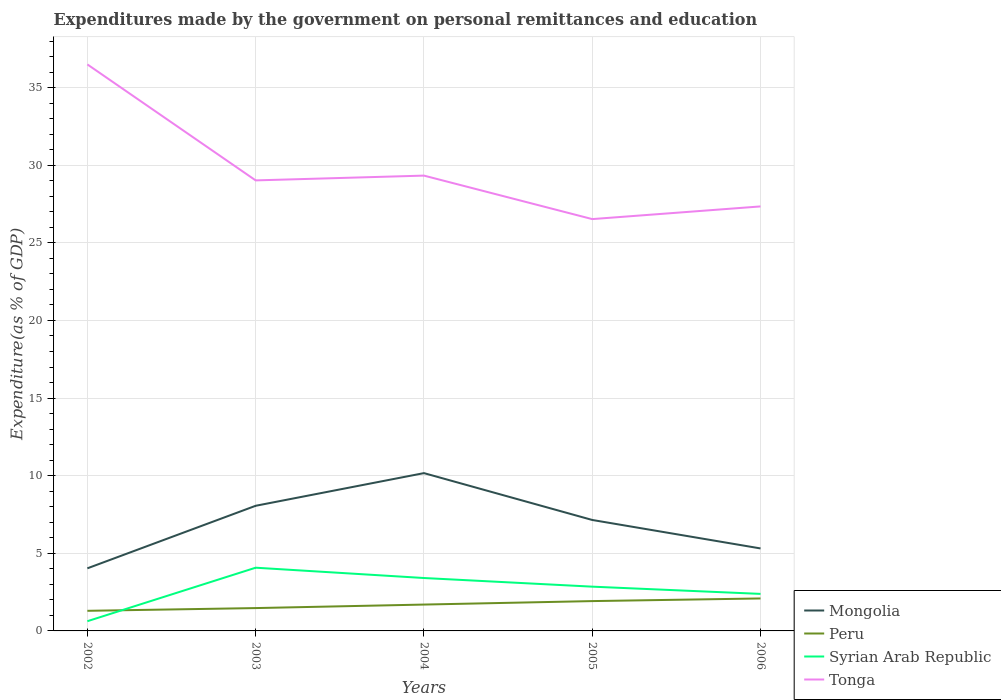Across all years, what is the maximum expenditures made by the government on personal remittances and education in Tonga?
Provide a succinct answer. 26.53. What is the total expenditures made by the government on personal remittances and education in Tonga in the graph?
Provide a succinct answer. 1.98. What is the difference between the highest and the second highest expenditures made by the government on personal remittances and education in Syrian Arab Republic?
Offer a very short reply. 3.45. What is the difference between the highest and the lowest expenditures made by the government on personal remittances and education in Peru?
Provide a short and direct response. 3. Is the expenditures made by the government on personal remittances and education in Tonga strictly greater than the expenditures made by the government on personal remittances and education in Syrian Arab Republic over the years?
Ensure brevity in your answer.  No. How many lines are there?
Ensure brevity in your answer.  4. What is the difference between two consecutive major ticks on the Y-axis?
Provide a succinct answer. 5. Are the values on the major ticks of Y-axis written in scientific E-notation?
Provide a short and direct response. No. Does the graph contain grids?
Offer a very short reply. Yes. What is the title of the graph?
Offer a terse response. Expenditures made by the government on personal remittances and education. What is the label or title of the X-axis?
Make the answer very short. Years. What is the label or title of the Y-axis?
Provide a short and direct response. Expenditure(as % of GDP). What is the Expenditure(as % of GDP) in Mongolia in 2002?
Offer a very short reply. 4.03. What is the Expenditure(as % of GDP) of Peru in 2002?
Ensure brevity in your answer.  1.3. What is the Expenditure(as % of GDP) of Syrian Arab Republic in 2002?
Offer a terse response. 0.63. What is the Expenditure(as % of GDP) in Tonga in 2002?
Provide a succinct answer. 36.49. What is the Expenditure(as % of GDP) of Mongolia in 2003?
Give a very brief answer. 8.06. What is the Expenditure(as % of GDP) in Peru in 2003?
Provide a short and direct response. 1.47. What is the Expenditure(as % of GDP) of Syrian Arab Republic in 2003?
Your answer should be compact. 4.07. What is the Expenditure(as % of GDP) in Tonga in 2003?
Ensure brevity in your answer.  29.02. What is the Expenditure(as % of GDP) in Mongolia in 2004?
Keep it short and to the point. 10.17. What is the Expenditure(as % of GDP) of Peru in 2004?
Provide a succinct answer. 1.7. What is the Expenditure(as % of GDP) in Syrian Arab Republic in 2004?
Your response must be concise. 3.41. What is the Expenditure(as % of GDP) of Tonga in 2004?
Ensure brevity in your answer.  29.33. What is the Expenditure(as % of GDP) in Mongolia in 2005?
Offer a very short reply. 7.15. What is the Expenditure(as % of GDP) in Peru in 2005?
Offer a very short reply. 1.92. What is the Expenditure(as % of GDP) of Syrian Arab Republic in 2005?
Provide a short and direct response. 2.85. What is the Expenditure(as % of GDP) of Tonga in 2005?
Your answer should be compact. 26.53. What is the Expenditure(as % of GDP) in Mongolia in 2006?
Ensure brevity in your answer.  5.31. What is the Expenditure(as % of GDP) of Peru in 2006?
Offer a very short reply. 2.09. What is the Expenditure(as % of GDP) of Syrian Arab Republic in 2006?
Make the answer very short. 2.39. What is the Expenditure(as % of GDP) in Tonga in 2006?
Offer a very short reply. 27.35. Across all years, what is the maximum Expenditure(as % of GDP) of Mongolia?
Provide a short and direct response. 10.17. Across all years, what is the maximum Expenditure(as % of GDP) in Peru?
Your response must be concise. 2.09. Across all years, what is the maximum Expenditure(as % of GDP) of Syrian Arab Republic?
Your answer should be compact. 4.07. Across all years, what is the maximum Expenditure(as % of GDP) of Tonga?
Offer a very short reply. 36.49. Across all years, what is the minimum Expenditure(as % of GDP) in Mongolia?
Keep it short and to the point. 4.03. Across all years, what is the minimum Expenditure(as % of GDP) of Peru?
Offer a very short reply. 1.3. Across all years, what is the minimum Expenditure(as % of GDP) of Syrian Arab Republic?
Offer a terse response. 0.63. Across all years, what is the minimum Expenditure(as % of GDP) of Tonga?
Your response must be concise. 26.53. What is the total Expenditure(as % of GDP) of Mongolia in the graph?
Your answer should be compact. 34.72. What is the total Expenditure(as % of GDP) in Peru in the graph?
Give a very brief answer. 8.48. What is the total Expenditure(as % of GDP) of Syrian Arab Republic in the graph?
Give a very brief answer. 13.34. What is the total Expenditure(as % of GDP) in Tonga in the graph?
Offer a very short reply. 148.72. What is the difference between the Expenditure(as % of GDP) in Mongolia in 2002 and that in 2003?
Provide a short and direct response. -4.03. What is the difference between the Expenditure(as % of GDP) in Peru in 2002 and that in 2003?
Provide a short and direct response. -0.18. What is the difference between the Expenditure(as % of GDP) in Syrian Arab Republic in 2002 and that in 2003?
Offer a terse response. -3.45. What is the difference between the Expenditure(as % of GDP) of Tonga in 2002 and that in 2003?
Provide a short and direct response. 7.47. What is the difference between the Expenditure(as % of GDP) of Mongolia in 2002 and that in 2004?
Give a very brief answer. -6.13. What is the difference between the Expenditure(as % of GDP) in Peru in 2002 and that in 2004?
Offer a very short reply. -0.4. What is the difference between the Expenditure(as % of GDP) of Syrian Arab Republic in 2002 and that in 2004?
Your answer should be compact. -2.78. What is the difference between the Expenditure(as % of GDP) of Tonga in 2002 and that in 2004?
Ensure brevity in your answer.  7.16. What is the difference between the Expenditure(as % of GDP) of Mongolia in 2002 and that in 2005?
Offer a very short reply. -3.12. What is the difference between the Expenditure(as % of GDP) of Peru in 2002 and that in 2005?
Your answer should be very brief. -0.63. What is the difference between the Expenditure(as % of GDP) in Syrian Arab Republic in 2002 and that in 2005?
Keep it short and to the point. -2.23. What is the difference between the Expenditure(as % of GDP) in Tonga in 2002 and that in 2005?
Offer a terse response. 9.96. What is the difference between the Expenditure(as % of GDP) of Mongolia in 2002 and that in 2006?
Provide a short and direct response. -1.28. What is the difference between the Expenditure(as % of GDP) of Peru in 2002 and that in 2006?
Ensure brevity in your answer.  -0.8. What is the difference between the Expenditure(as % of GDP) of Syrian Arab Republic in 2002 and that in 2006?
Offer a very short reply. -1.76. What is the difference between the Expenditure(as % of GDP) of Tonga in 2002 and that in 2006?
Make the answer very short. 9.15. What is the difference between the Expenditure(as % of GDP) of Mongolia in 2003 and that in 2004?
Offer a very short reply. -2.1. What is the difference between the Expenditure(as % of GDP) in Peru in 2003 and that in 2004?
Make the answer very short. -0.23. What is the difference between the Expenditure(as % of GDP) of Syrian Arab Republic in 2003 and that in 2004?
Ensure brevity in your answer.  0.66. What is the difference between the Expenditure(as % of GDP) in Tonga in 2003 and that in 2004?
Give a very brief answer. -0.31. What is the difference between the Expenditure(as % of GDP) in Mongolia in 2003 and that in 2005?
Provide a succinct answer. 0.91. What is the difference between the Expenditure(as % of GDP) of Peru in 2003 and that in 2005?
Your answer should be very brief. -0.45. What is the difference between the Expenditure(as % of GDP) in Syrian Arab Republic in 2003 and that in 2005?
Ensure brevity in your answer.  1.22. What is the difference between the Expenditure(as % of GDP) in Tonga in 2003 and that in 2005?
Keep it short and to the point. 2.49. What is the difference between the Expenditure(as % of GDP) in Mongolia in 2003 and that in 2006?
Your answer should be compact. 2.75. What is the difference between the Expenditure(as % of GDP) in Peru in 2003 and that in 2006?
Ensure brevity in your answer.  -0.62. What is the difference between the Expenditure(as % of GDP) in Syrian Arab Republic in 2003 and that in 2006?
Offer a terse response. 1.69. What is the difference between the Expenditure(as % of GDP) in Tonga in 2003 and that in 2006?
Your answer should be compact. 1.68. What is the difference between the Expenditure(as % of GDP) of Mongolia in 2004 and that in 2005?
Your answer should be very brief. 3.02. What is the difference between the Expenditure(as % of GDP) in Peru in 2004 and that in 2005?
Give a very brief answer. -0.22. What is the difference between the Expenditure(as % of GDP) of Syrian Arab Republic in 2004 and that in 2005?
Your answer should be compact. 0.56. What is the difference between the Expenditure(as % of GDP) of Tonga in 2004 and that in 2005?
Provide a short and direct response. 2.8. What is the difference between the Expenditure(as % of GDP) in Mongolia in 2004 and that in 2006?
Make the answer very short. 4.85. What is the difference between the Expenditure(as % of GDP) in Peru in 2004 and that in 2006?
Make the answer very short. -0.39. What is the difference between the Expenditure(as % of GDP) in Syrian Arab Republic in 2004 and that in 2006?
Give a very brief answer. 1.02. What is the difference between the Expenditure(as % of GDP) of Tonga in 2004 and that in 2006?
Keep it short and to the point. 1.98. What is the difference between the Expenditure(as % of GDP) of Mongolia in 2005 and that in 2006?
Make the answer very short. 1.83. What is the difference between the Expenditure(as % of GDP) in Peru in 2005 and that in 2006?
Make the answer very short. -0.17. What is the difference between the Expenditure(as % of GDP) in Syrian Arab Republic in 2005 and that in 2006?
Your answer should be compact. 0.47. What is the difference between the Expenditure(as % of GDP) of Tonga in 2005 and that in 2006?
Give a very brief answer. -0.82. What is the difference between the Expenditure(as % of GDP) in Mongolia in 2002 and the Expenditure(as % of GDP) in Peru in 2003?
Your response must be concise. 2.56. What is the difference between the Expenditure(as % of GDP) of Mongolia in 2002 and the Expenditure(as % of GDP) of Syrian Arab Republic in 2003?
Offer a terse response. -0.04. What is the difference between the Expenditure(as % of GDP) of Mongolia in 2002 and the Expenditure(as % of GDP) of Tonga in 2003?
Provide a short and direct response. -24.99. What is the difference between the Expenditure(as % of GDP) in Peru in 2002 and the Expenditure(as % of GDP) in Syrian Arab Republic in 2003?
Keep it short and to the point. -2.78. What is the difference between the Expenditure(as % of GDP) in Peru in 2002 and the Expenditure(as % of GDP) in Tonga in 2003?
Offer a very short reply. -27.73. What is the difference between the Expenditure(as % of GDP) of Syrian Arab Republic in 2002 and the Expenditure(as % of GDP) of Tonga in 2003?
Give a very brief answer. -28.4. What is the difference between the Expenditure(as % of GDP) in Mongolia in 2002 and the Expenditure(as % of GDP) in Peru in 2004?
Your answer should be very brief. 2.33. What is the difference between the Expenditure(as % of GDP) of Mongolia in 2002 and the Expenditure(as % of GDP) of Syrian Arab Republic in 2004?
Your answer should be very brief. 0.62. What is the difference between the Expenditure(as % of GDP) of Mongolia in 2002 and the Expenditure(as % of GDP) of Tonga in 2004?
Make the answer very short. -25.3. What is the difference between the Expenditure(as % of GDP) in Peru in 2002 and the Expenditure(as % of GDP) in Syrian Arab Republic in 2004?
Provide a succinct answer. -2.11. What is the difference between the Expenditure(as % of GDP) in Peru in 2002 and the Expenditure(as % of GDP) in Tonga in 2004?
Make the answer very short. -28.03. What is the difference between the Expenditure(as % of GDP) of Syrian Arab Republic in 2002 and the Expenditure(as % of GDP) of Tonga in 2004?
Ensure brevity in your answer.  -28.7. What is the difference between the Expenditure(as % of GDP) in Mongolia in 2002 and the Expenditure(as % of GDP) in Peru in 2005?
Your answer should be compact. 2.11. What is the difference between the Expenditure(as % of GDP) in Mongolia in 2002 and the Expenditure(as % of GDP) in Syrian Arab Republic in 2005?
Offer a very short reply. 1.18. What is the difference between the Expenditure(as % of GDP) in Mongolia in 2002 and the Expenditure(as % of GDP) in Tonga in 2005?
Your answer should be compact. -22.5. What is the difference between the Expenditure(as % of GDP) of Peru in 2002 and the Expenditure(as % of GDP) of Syrian Arab Republic in 2005?
Ensure brevity in your answer.  -1.56. What is the difference between the Expenditure(as % of GDP) of Peru in 2002 and the Expenditure(as % of GDP) of Tonga in 2005?
Your response must be concise. -25.23. What is the difference between the Expenditure(as % of GDP) in Syrian Arab Republic in 2002 and the Expenditure(as % of GDP) in Tonga in 2005?
Your answer should be very brief. -25.9. What is the difference between the Expenditure(as % of GDP) of Mongolia in 2002 and the Expenditure(as % of GDP) of Peru in 2006?
Make the answer very short. 1.94. What is the difference between the Expenditure(as % of GDP) in Mongolia in 2002 and the Expenditure(as % of GDP) in Syrian Arab Republic in 2006?
Your answer should be compact. 1.65. What is the difference between the Expenditure(as % of GDP) in Mongolia in 2002 and the Expenditure(as % of GDP) in Tonga in 2006?
Provide a short and direct response. -23.31. What is the difference between the Expenditure(as % of GDP) in Peru in 2002 and the Expenditure(as % of GDP) in Syrian Arab Republic in 2006?
Ensure brevity in your answer.  -1.09. What is the difference between the Expenditure(as % of GDP) in Peru in 2002 and the Expenditure(as % of GDP) in Tonga in 2006?
Provide a short and direct response. -26.05. What is the difference between the Expenditure(as % of GDP) of Syrian Arab Republic in 2002 and the Expenditure(as % of GDP) of Tonga in 2006?
Offer a terse response. -26.72. What is the difference between the Expenditure(as % of GDP) in Mongolia in 2003 and the Expenditure(as % of GDP) in Peru in 2004?
Provide a succinct answer. 6.36. What is the difference between the Expenditure(as % of GDP) of Mongolia in 2003 and the Expenditure(as % of GDP) of Syrian Arab Republic in 2004?
Your answer should be very brief. 4.65. What is the difference between the Expenditure(as % of GDP) of Mongolia in 2003 and the Expenditure(as % of GDP) of Tonga in 2004?
Offer a very short reply. -21.27. What is the difference between the Expenditure(as % of GDP) in Peru in 2003 and the Expenditure(as % of GDP) in Syrian Arab Republic in 2004?
Your answer should be compact. -1.94. What is the difference between the Expenditure(as % of GDP) in Peru in 2003 and the Expenditure(as % of GDP) in Tonga in 2004?
Give a very brief answer. -27.86. What is the difference between the Expenditure(as % of GDP) in Syrian Arab Republic in 2003 and the Expenditure(as % of GDP) in Tonga in 2004?
Offer a terse response. -25.26. What is the difference between the Expenditure(as % of GDP) in Mongolia in 2003 and the Expenditure(as % of GDP) in Peru in 2005?
Give a very brief answer. 6.14. What is the difference between the Expenditure(as % of GDP) in Mongolia in 2003 and the Expenditure(as % of GDP) in Syrian Arab Republic in 2005?
Make the answer very short. 5.21. What is the difference between the Expenditure(as % of GDP) of Mongolia in 2003 and the Expenditure(as % of GDP) of Tonga in 2005?
Provide a succinct answer. -18.47. What is the difference between the Expenditure(as % of GDP) of Peru in 2003 and the Expenditure(as % of GDP) of Syrian Arab Republic in 2005?
Your answer should be compact. -1.38. What is the difference between the Expenditure(as % of GDP) of Peru in 2003 and the Expenditure(as % of GDP) of Tonga in 2005?
Offer a very short reply. -25.06. What is the difference between the Expenditure(as % of GDP) in Syrian Arab Republic in 2003 and the Expenditure(as % of GDP) in Tonga in 2005?
Your response must be concise. -22.46. What is the difference between the Expenditure(as % of GDP) of Mongolia in 2003 and the Expenditure(as % of GDP) of Peru in 2006?
Your answer should be compact. 5.97. What is the difference between the Expenditure(as % of GDP) in Mongolia in 2003 and the Expenditure(as % of GDP) in Syrian Arab Republic in 2006?
Give a very brief answer. 5.68. What is the difference between the Expenditure(as % of GDP) in Mongolia in 2003 and the Expenditure(as % of GDP) in Tonga in 2006?
Make the answer very short. -19.28. What is the difference between the Expenditure(as % of GDP) of Peru in 2003 and the Expenditure(as % of GDP) of Syrian Arab Republic in 2006?
Provide a short and direct response. -0.91. What is the difference between the Expenditure(as % of GDP) of Peru in 2003 and the Expenditure(as % of GDP) of Tonga in 2006?
Provide a short and direct response. -25.87. What is the difference between the Expenditure(as % of GDP) in Syrian Arab Republic in 2003 and the Expenditure(as % of GDP) in Tonga in 2006?
Give a very brief answer. -23.27. What is the difference between the Expenditure(as % of GDP) in Mongolia in 2004 and the Expenditure(as % of GDP) in Peru in 2005?
Your answer should be very brief. 8.24. What is the difference between the Expenditure(as % of GDP) of Mongolia in 2004 and the Expenditure(as % of GDP) of Syrian Arab Republic in 2005?
Provide a short and direct response. 7.31. What is the difference between the Expenditure(as % of GDP) in Mongolia in 2004 and the Expenditure(as % of GDP) in Tonga in 2005?
Your answer should be compact. -16.36. What is the difference between the Expenditure(as % of GDP) in Peru in 2004 and the Expenditure(as % of GDP) in Syrian Arab Republic in 2005?
Offer a terse response. -1.15. What is the difference between the Expenditure(as % of GDP) of Peru in 2004 and the Expenditure(as % of GDP) of Tonga in 2005?
Ensure brevity in your answer.  -24.83. What is the difference between the Expenditure(as % of GDP) of Syrian Arab Republic in 2004 and the Expenditure(as % of GDP) of Tonga in 2005?
Give a very brief answer. -23.12. What is the difference between the Expenditure(as % of GDP) in Mongolia in 2004 and the Expenditure(as % of GDP) in Peru in 2006?
Offer a very short reply. 8.07. What is the difference between the Expenditure(as % of GDP) in Mongolia in 2004 and the Expenditure(as % of GDP) in Syrian Arab Republic in 2006?
Offer a terse response. 7.78. What is the difference between the Expenditure(as % of GDP) of Mongolia in 2004 and the Expenditure(as % of GDP) of Tonga in 2006?
Keep it short and to the point. -17.18. What is the difference between the Expenditure(as % of GDP) of Peru in 2004 and the Expenditure(as % of GDP) of Syrian Arab Republic in 2006?
Provide a short and direct response. -0.69. What is the difference between the Expenditure(as % of GDP) in Peru in 2004 and the Expenditure(as % of GDP) in Tonga in 2006?
Provide a succinct answer. -25.65. What is the difference between the Expenditure(as % of GDP) in Syrian Arab Republic in 2004 and the Expenditure(as % of GDP) in Tonga in 2006?
Ensure brevity in your answer.  -23.94. What is the difference between the Expenditure(as % of GDP) of Mongolia in 2005 and the Expenditure(as % of GDP) of Peru in 2006?
Make the answer very short. 5.06. What is the difference between the Expenditure(as % of GDP) of Mongolia in 2005 and the Expenditure(as % of GDP) of Syrian Arab Republic in 2006?
Give a very brief answer. 4.76. What is the difference between the Expenditure(as % of GDP) in Mongolia in 2005 and the Expenditure(as % of GDP) in Tonga in 2006?
Your response must be concise. -20.2. What is the difference between the Expenditure(as % of GDP) of Peru in 2005 and the Expenditure(as % of GDP) of Syrian Arab Republic in 2006?
Your answer should be compact. -0.46. What is the difference between the Expenditure(as % of GDP) in Peru in 2005 and the Expenditure(as % of GDP) in Tonga in 2006?
Offer a very short reply. -25.42. What is the difference between the Expenditure(as % of GDP) in Syrian Arab Republic in 2005 and the Expenditure(as % of GDP) in Tonga in 2006?
Your answer should be very brief. -24.49. What is the average Expenditure(as % of GDP) of Mongolia per year?
Your answer should be compact. 6.94. What is the average Expenditure(as % of GDP) in Peru per year?
Give a very brief answer. 1.7. What is the average Expenditure(as % of GDP) in Syrian Arab Republic per year?
Make the answer very short. 2.67. What is the average Expenditure(as % of GDP) of Tonga per year?
Keep it short and to the point. 29.74. In the year 2002, what is the difference between the Expenditure(as % of GDP) of Mongolia and Expenditure(as % of GDP) of Peru?
Offer a very short reply. 2.74. In the year 2002, what is the difference between the Expenditure(as % of GDP) in Mongolia and Expenditure(as % of GDP) in Syrian Arab Republic?
Give a very brief answer. 3.41. In the year 2002, what is the difference between the Expenditure(as % of GDP) in Mongolia and Expenditure(as % of GDP) in Tonga?
Your answer should be compact. -32.46. In the year 2002, what is the difference between the Expenditure(as % of GDP) of Peru and Expenditure(as % of GDP) of Syrian Arab Republic?
Offer a very short reply. 0.67. In the year 2002, what is the difference between the Expenditure(as % of GDP) of Peru and Expenditure(as % of GDP) of Tonga?
Give a very brief answer. -35.2. In the year 2002, what is the difference between the Expenditure(as % of GDP) of Syrian Arab Republic and Expenditure(as % of GDP) of Tonga?
Offer a very short reply. -35.87. In the year 2003, what is the difference between the Expenditure(as % of GDP) in Mongolia and Expenditure(as % of GDP) in Peru?
Give a very brief answer. 6.59. In the year 2003, what is the difference between the Expenditure(as % of GDP) in Mongolia and Expenditure(as % of GDP) in Syrian Arab Republic?
Your answer should be very brief. 3.99. In the year 2003, what is the difference between the Expenditure(as % of GDP) in Mongolia and Expenditure(as % of GDP) in Tonga?
Your answer should be very brief. -20.96. In the year 2003, what is the difference between the Expenditure(as % of GDP) of Peru and Expenditure(as % of GDP) of Syrian Arab Republic?
Your response must be concise. -2.6. In the year 2003, what is the difference between the Expenditure(as % of GDP) of Peru and Expenditure(as % of GDP) of Tonga?
Provide a succinct answer. -27.55. In the year 2003, what is the difference between the Expenditure(as % of GDP) in Syrian Arab Republic and Expenditure(as % of GDP) in Tonga?
Give a very brief answer. -24.95. In the year 2004, what is the difference between the Expenditure(as % of GDP) of Mongolia and Expenditure(as % of GDP) of Peru?
Provide a succinct answer. 8.47. In the year 2004, what is the difference between the Expenditure(as % of GDP) of Mongolia and Expenditure(as % of GDP) of Syrian Arab Republic?
Ensure brevity in your answer.  6.76. In the year 2004, what is the difference between the Expenditure(as % of GDP) of Mongolia and Expenditure(as % of GDP) of Tonga?
Provide a succinct answer. -19.16. In the year 2004, what is the difference between the Expenditure(as % of GDP) of Peru and Expenditure(as % of GDP) of Syrian Arab Republic?
Provide a succinct answer. -1.71. In the year 2004, what is the difference between the Expenditure(as % of GDP) of Peru and Expenditure(as % of GDP) of Tonga?
Your answer should be very brief. -27.63. In the year 2004, what is the difference between the Expenditure(as % of GDP) of Syrian Arab Republic and Expenditure(as % of GDP) of Tonga?
Offer a very short reply. -25.92. In the year 2005, what is the difference between the Expenditure(as % of GDP) in Mongolia and Expenditure(as % of GDP) in Peru?
Provide a succinct answer. 5.23. In the year 2005, what is the difference between the Expenditure(as % of GDP) in Mongolia and Expenditure(as % of GDP) in Syrian Arab Republic?
Keep it short and to the point. 4.3. In the year 2005, what is the difference between the Expenditure(as % of GDP) in Mongolia and Expenditure(as % of GDP) in Tonga?
Make the answer very short. -19.38. In the year 2005, what is the difference between the Expenditure(as % of GDP) of Peru and Expenditure(as % of GDP) of Syrian Arab Republic?
Ensure brevity in your answer.  -0.93. In the year 2005, what is the difference between the Expenditure(as % of GDP) in Peru and Expenditure(as % of GDP) in Tonga?
Make the answer very short. -24.61. In the year 2005, what is the difference between the Expenditure(as % of GDP) in Syrian Arab Republic and Expenditure(as % of GDP) in Tonga?
Your answer should be very brief. -23.68. In the year 2006, what is the difference between the Expenditure(as % of GDP) of Mongolia and Expenditure(as % of GDP) of Peru?
Your response must be concise. 3.22. In the year 2006, what is the difference between the Expenditure(as % of GDP) of Mongolia and Expenditure(as % of GDP) of Syrian Arab Republic?
Your response must be concise. 2.93. In the year 2006, what is the difference between the Expenditure(as % of GDP) in Mongolia and Expenditure(as % of GDP) in Tonga?
Provide a succinct answer. -22.03. In the year 2006, what is the difference between the Expenditure(as % of GDP) in Peru and Expenditure(as % of GDP) in Syrian Arab Republic?
Your response must be concise. -0.29. In the year 2006, what is the difference between the Expenditure(as % of GDP) of Peru and Expenditure(as % of GDP) of Tonga?
Provide a succinct answer. -25.25. In the year 2006, what is the difference between the Expenditure(as % of GDP) in Syrian Arab Republic and Expenditure(as % of GDP) in Tonga?
Provide a short and direct response. -24.96. What is the ratio of the Expenditure(as % of GDP) of Mongolia in 2002 to that in 2003?
Your answer should be very brief. 0.5. What is the ratio of the Expenditure(as % of GDP) in Peru in 2002 to that in 2003?
Your answer should be very brief. 0.88. What is the ratio of the Expenditure(as % of GDP) in Syrian Arab Republic in 2002 to that in 2003?
Your response must be concise. 0.15. What is the ratio of the Expenditure(as % of GDP) in Tonga in 2002 to that in 2003?
Offer a terse response. 1.26. What is the ratio of the Expenditure(as % of GDP) in Mongolia in 2002 to that in 2004?
Your response must be concise. 0.4. What is the ratio of the Expenditure(as % of GDP) in Peru in 2002 to that in 2004?
Offer a terse response. 0.76. What is the ratio of the Expenditure(as % of GDP) of Syrian Arab Republic in 2002 to that in 2004?
Offer a terse response. 0.18. What is the ratio of the Expenditure(as % of GDP) of Tonga in 2002 to that in 2004?
Your response must be concise. 1.24. What is the ratio of the Expenditure(as % of GDP) of Mongolia in 2002 to that in 2005?
Your answer should be very brief. 0.56. What is the ratio of the Expenditure(as % of GDP) of Peru in 2002 to that in 2005?
Offer a very short reply. 0.67. What is the ratio of the Expenditure(as % of GDP) in Syrian Arab Republic in 2002 to that in 2005?
Provide a short and direct response. 0.22. What is the ratio of the Expenditure(as % of GDP) of Tonga in 2002 to that in 2005?
Offer a terse response. 1.38. What is the ratio of the Expenditure(as % of GDP) in Mongolia in 2002 to that in 2006?
Your answer should be very brief. 0.76. What is the ratio of the Expenditure(as % of GDP) of Peru in 2002 to that in 2006?
Give a very brief answer. 0.62. What is the ratio of the Expenditure(as % of GDP) in Syrian Arab Republic in 2002 to that in 2006?
Keep it short and to the point. 0.26. What is the ratio of the Expenditure(as % of GDP) in Tonga in 2002 to that in 2006?
Your answer should be compact. 1.33. What is the ratio of the Expenditure(as % of GDP) in Mongolia in 2003 to that in 2004?
Your response must be concise. 0.79. What is the ratio of the Expenditure(as % of GDP) of Peru in 2003 to that in 2004?
Keep it short and to the point. 0.87. What is the ratio of the Expenditure(as % of GDP) in Syrian Arab Republic in 2003 to that in 2004?
Offer a terse response. 1.2. What is the ratio of the Expenditure(as % of GDP) in Tonga in 2003 to that in 2004?
Offer a terse response. 0.99. What is the ratio of the Expenditure(as % of GDP) of Mongolia in 2003 to that in 2005?
Your response must be concise. 1.13. What is the ratio of the Expenditure(as % of GDP) of Peru in 2003 to that in 2005?
Offer a terse response. 0.77. What is the ratio of the Expenditure(as % of GDP) in Syrian Arab Republic in 2003 to that in 2005?
Provide a short and direct response. 1.43. What is the ratio of the Expenditure(as % of GDP) of Tonga in 2003 to that in 2005?
Offer a terse response. 1.09. What is the ratio of the Expenditure(as % of GDP) in Mongolia in 2003 to that in 2006?
Provide a short and direct response. 1.52. What is the ratio of the Expenditure(as % of GDP) of Peru in 2003 to that in 2006?
Your answer should be compact. 0.7. What is the ratio of the Expenditure(as % of GDP) in Syrian Arab Republic in 2003 to that in 2006?
Your answer should be very brief. 1.71. What is the ratio of the Expenditure(as % of GDP) in Tonga in 2003 to that in 2006?
Keep it short and to the point. 1.06. What is the ratio of the Expenditure(as % of GDP) of Mongolia in 2004 to that in 2005?
Provide a succinct answer. 1.42. What is the ratio of the Expenditure(as % of GDP) of Peru in 2004 to that in 2005?
Your answer should be very brief. 0.88. What is the ratio of the Expenditure(as % of GDP) of Syrian Arab Republic in 2004 to that in 2005?
Keep it short and to the point. 1.2. What is the ratio of the Expenditure(as % of GDP) in Tonga in 2004 to that in 2005?
Give a very brief answer. 1.11. What is the ratio of the Expenditure(as % of GDP) of Mongolia in 2004 to that in 2006?
Provide a succinct answer. 1.91. What is the ratio of the Expenditure(as % of GDP) of Peru in 2004 to that in 2006?
Offer a very short reply. 0.81. What is the ratio of the Expenditure(as % of GDP) in Syrian Arab Republic in 2004 to that in 2006?
Offer a very short reply. 1.43. What is the ratio of the Expenditure(as % of GDP) of Tonga in 2004 to that in 2006?
Your response must be concise. 1.07. What is the ratio of the Expenditure(as % of GDP) in Mongolia in 2005 to that in 2006?
Provide a short and direct response. 1.35. What is the ratio of the Expenditure(as % of GDP) in Peru in 2005 to that in 2006?
Keep it short and to the point. 0.92. What is the ratio of the Expenditure(as % of GDP) in Syrian Arab Republic in 2005 to that in 2006?
Your response must be concise. 1.2. What is the ratio of the Expenditure(as % of GDP) of Tonga in 2005 to that in 2006?
Your answer should be compact. 0.97. What is the difference between the highest and the second highest Expenditure(as % of GDP) in Mongolia?
Give a very brief answer. 2.1. What is the difference between the highest and the second highest Expenditure(as % of GDP) of Peru?
Offer a terse response. 0.17. What is the difference between the highest and the second highest Expenditure(as % of GDP) in Syrian Arab Republic?
Make the answer very short. 0.66. What is the difference between the highest and the second highest Expenditure(as % of GDP) in Tonga?
Offer a very short reply. 7.16. What is the difference between the highest and the lowest Expenditure(as % of GDP) in Mongolia?
Offer a terse response. 6.13. What is the difference between the highest and the lowest Expenditure(as % of GDP) of Peru?
Offer a very short reply. 0.8. What is the difference between the highest and the lowest Expenditure(as % of GDP) of Syrian Arab Republic?
Your response must be concise. 3.45. What is the difference between the highest and the lowest Expenditure(as % of GDP) of Tonga?
Your answer should be compact. 9.96. 